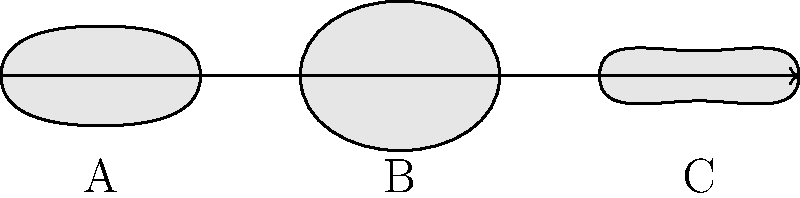During your daily commute, you notice different lens shapes in various camera setups. Based on the cross-sectional diagrams of three lenses (A, B, and C) shown above, which one represents a telephoto lens typically used for capturing distant subjects? To identify the telephoto lens, let's analyze each lens shape:

1. Lens A: This lens has a symmetrical convex shape on both sides. It represents a standard or normal lens, which has a focal length similar to the diagonal of the image sensor.

2. Lens B: This lens has a more pronounced convex shape on both sides compared to Lens A. It represents a wide-angle lens, which has a shorter focal length and captures a wider field of view.

3. Lens C: This lens has a less pronounced convex shape on both sides compared to Lens A. It represents a telephoto lens, which has a longer focal length and is used for capturing distant subjects.

Telephoto lenses are characterized by their longer focal lengths, which results in a narrower angle of view and higher magnification. This is achieved by having a flatter lens profile, as seen in Lens C.

The flatter profile of Lens C allows for a longer optical path within the lens body, which is crucial for achieving the telephoto effect without making the lens excessively long physically.
Answer: C 